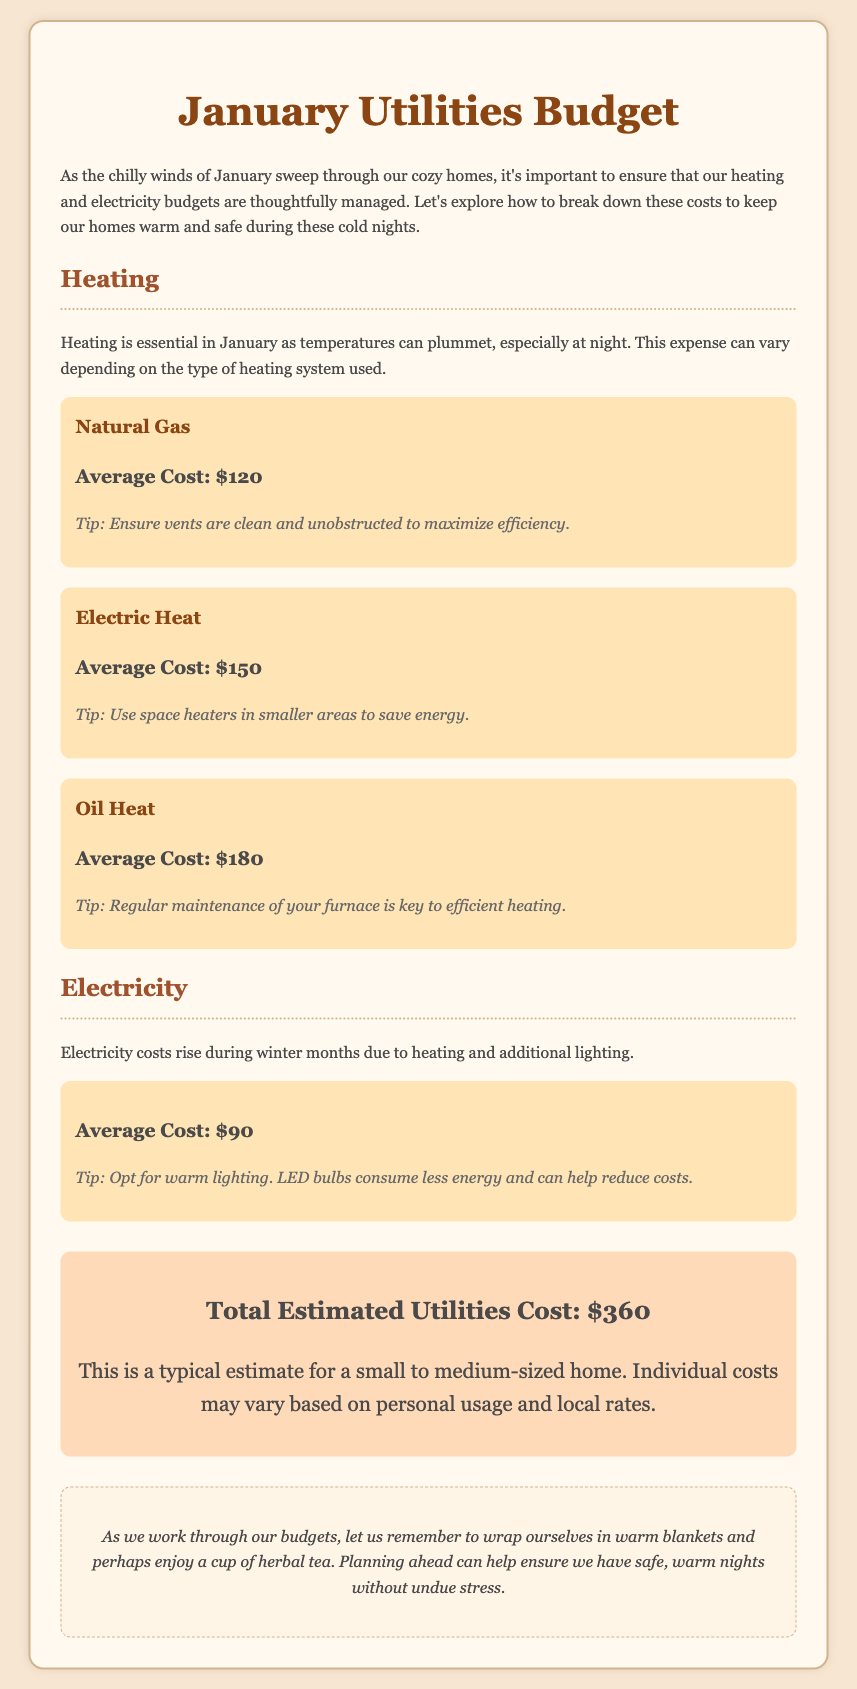What is the average cost of natural gas? The average cost of natural gas is explicitly stated in the document.
Answer: $120 What is the total estimated utilities cost? The total estimated utilities cost is mentioned as a single figure at the end of the document.
Answer: $360 What tip is provided for electric heat? The document includes specific tips for each heating type, which includes information for electric heat.
Answer: Use space heaters in smaller areas to save energy Which heating system has the highest average cost? The average costs for heating systems are compared within the document, highlighting which system is more expensive.
Answer: Oil Heat How much is the average cost of electricity? The document provides average costs for various utilities, including electricity.
Answer: $90 What type of advice is given at the end of the document? The document concludes with a section offering advice, summarizing the overall sentiment and suggestions.
Answer: Wrap ourselves in warm blankets and perhaps enjoy a cup of herbal tea What is the average cost of oil heat? The document specifies average costs for heating methods, including oil heat.
Answer: $180 What should be ensured to maximize efficiency in heating? The document gives a specific tip related to maintaining heating efficiency.
Answer: Ensure vents are clean and unobstructed 